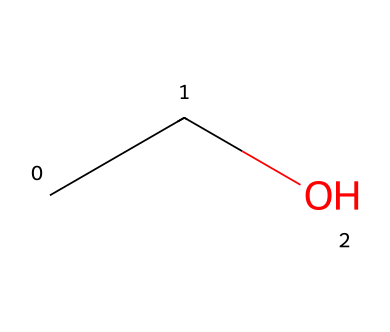What is the molecular formula of this compound? The SMILES representation "CCO" indicates that there are 2 carbon atoms (C) and 6 hydrogen atoms (H), along with 1 oxygen atom (O). Therefore, when combined, the molecular formula is C2H6O.
Answer: C2H6O How many carbon atoms are present in this structure? By examining the SMILES notation "CCO", we can see the two 'C' letters, which represent two carbon atoms.
Answer: 2 What type of alcohol is represented by this structure? This structure represents ethanol, which is classified as a primary alcohol due to its hydroxyl (-OH) group being attached to a carbon that is only connected to one other carbon atom.
Answer: primary alcohol How many hydrogen atoms are attached to the oxygen atom? In the structure of ethanol represented by "CCO", the single oxygen atom is part of the hydroxyl (-OH) group. In ethanol, the oxygen is bonded to one hydrogen atom.
Answer: 1 What type of functional group is present in this compound? The presence of the hydroxyl (-OH) group in the structure indicates that this compound has an alcohol functional group.
Answer: alcohol Is this compound soluble in water? Ethanol is known to be polar due to its -OH group, which allows it to dissolve well in water. The structure supports that it is a soluble compound.
Answer: yes 